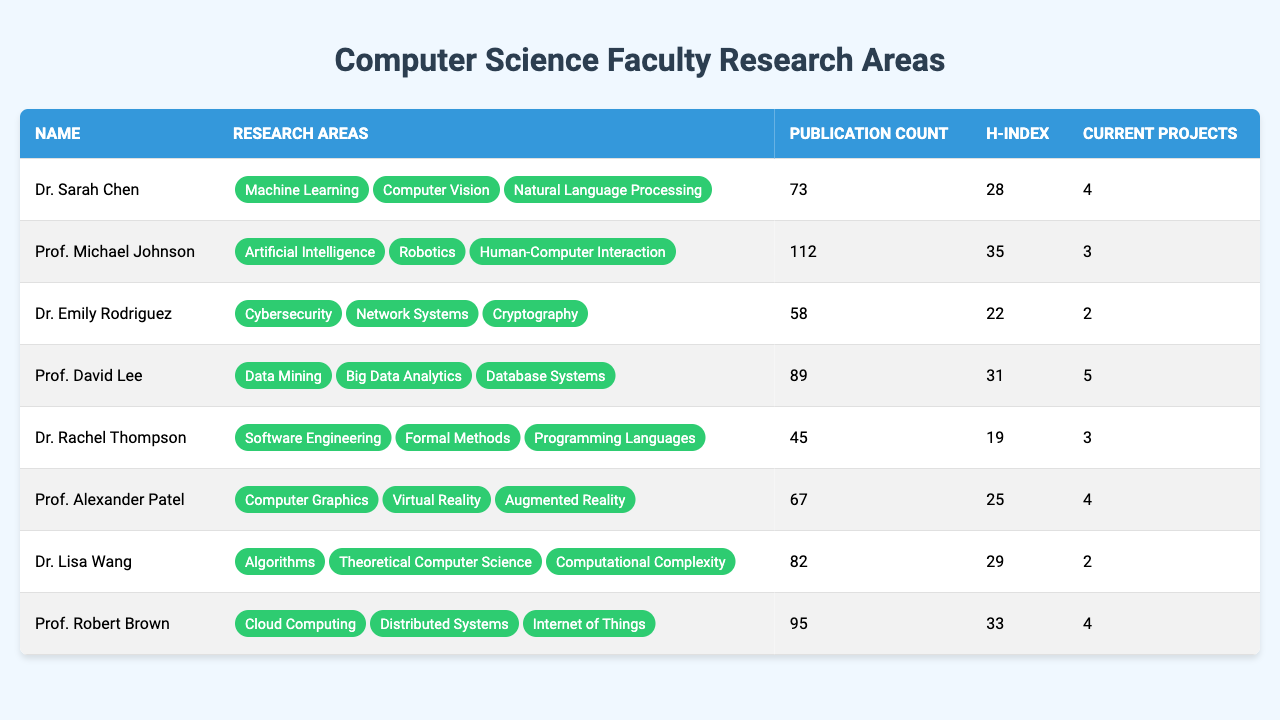What is the publication count of Prof. Michael Johnson? According to the table, under the column for publication count, Prof. Michael Johnson is listed with a publication count of 112.
Answer: 112 Which faculty member has the highest h-index? By reviewing the h-index column, we see that Prof. Michael Johnson has the highest h-index at 35, compared to others listed.
Answer: Prof. Michael Johnson How many current projects does Dr. Lisa Wang have? Looking at the current projects column, Dr. Lisa Wang is shown to have 2 current projects.
Answer: 2 Who are the faculty members that work in Cybersecurity? From the research areas column, Dr. Emily Rodriguez is the only faculty member listed with a focus on Cybersecurity.
Answer: Dr. Emily Rodriguez What is the average publication count of all faculty members? The sum of the publication counts is (73 + 112 + 58 + 89 + 45 + 67 + 82 + 95) = 621. There are 8 faculty members, so the average publication count is 621/8 = 77.625.
Answer: 77.625 Does any faculty member have a publication count less than 50? Reviewing the publication counts, we see that Dr. Rachel Thompson has a publication count of 45, which is less than 50.
Answer: Yes How many faculty members have their research areas related to Data? By checking the research areas listed, we find that two faculty members, Prof. David Lee (Data Mining, Big Data Analytics, Database Systems) and Dr. Lisa Wang (Theoretical Computer Science), have research areas related to data.
Answer: 2 What is the difference in publication counts between the faculty member with the highest and lowest publication counts? The highest publication count is 112 (Prof. Michael Johnson) and the lowest is 45 (Dr. Rachel Thompson). The difference is 112 - 45 = 67.
Answer: 67 Which research area appears most frequently among faculty members? None of the research areas are listed more than once; therefore, each area is unique to a faculty member.
Answer: None If we combine the current projects of both Dr. Sarah Chen and Prof. Alexander Patel, how many current projects do they have together? Dr. Sarah Chen has 4 current projects, and Prof. Alexander Patel also has 4 current projects. Totaling these gives us 4 + 4 = 8 current projects.
Answer: 8 